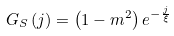Convert formula to latex. <formula><loc_0><loc_0><loc_500><loc_500>G _ { S } \left ( j \right ) = \left ( 1 - m ^ { 2 } \right ) e ^ { - \frac { j } { \xi } }</formula> 